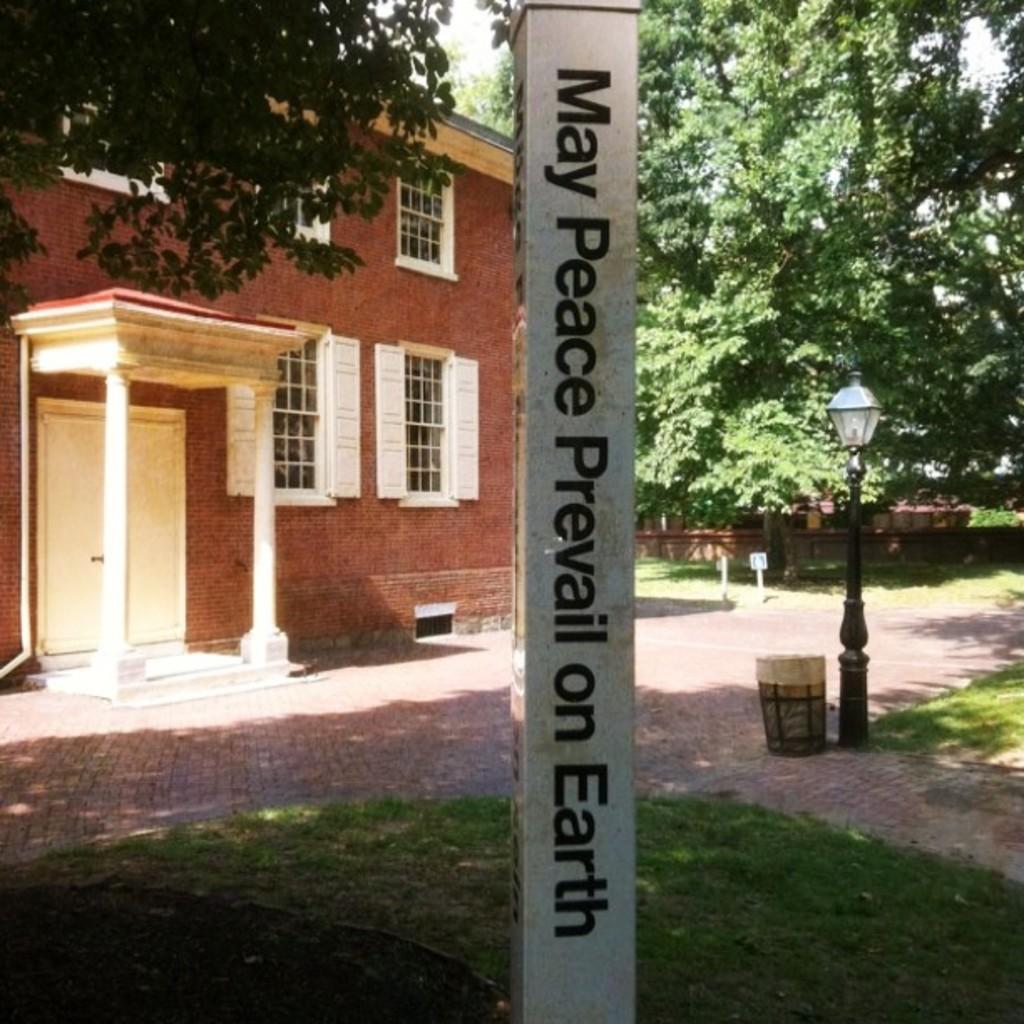Can you describe this image briefly? In this picture I can see letters on the pole, there is a house, there is a light, there is a dustbin and there are trees. 